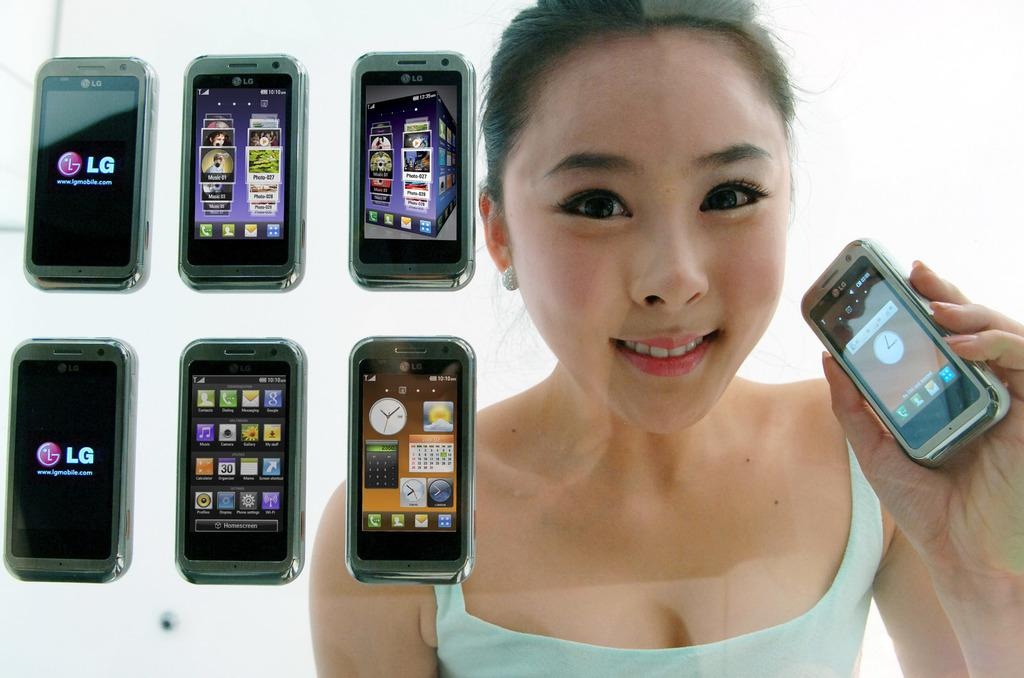<image>
Provide a brief description of the given image. The woman is hold up a small phone with other LG phones shown next to her. 